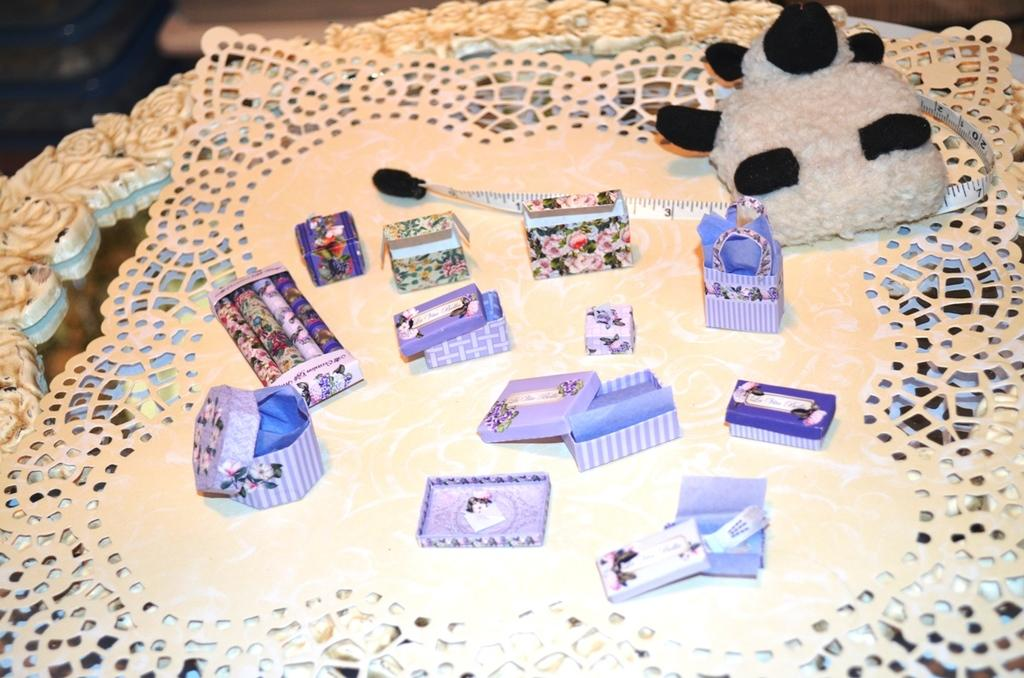What is the main piece of furniture in the image? There is a table in the image. What is on the table? The table has a mat on it, and there is a toy, a measuring tape, and tiny gift boxes on the mat. What type of toy can be seen on the mat? There is a toy on the mat, but the specific type of toy is not mentioned in the facts. What tool is used for measuring on the mat? There is a measuring tape on the mat. What else is present on the mat besides the measuring tape? There are tiny gift boxes on the mat. Can you describe the background of the image? The background of the image is blurry. Can you see the ocean in the background of the image? No, the ocean is not present in the image. The background is blurry, but there is no mention of an ocean or any water body. 